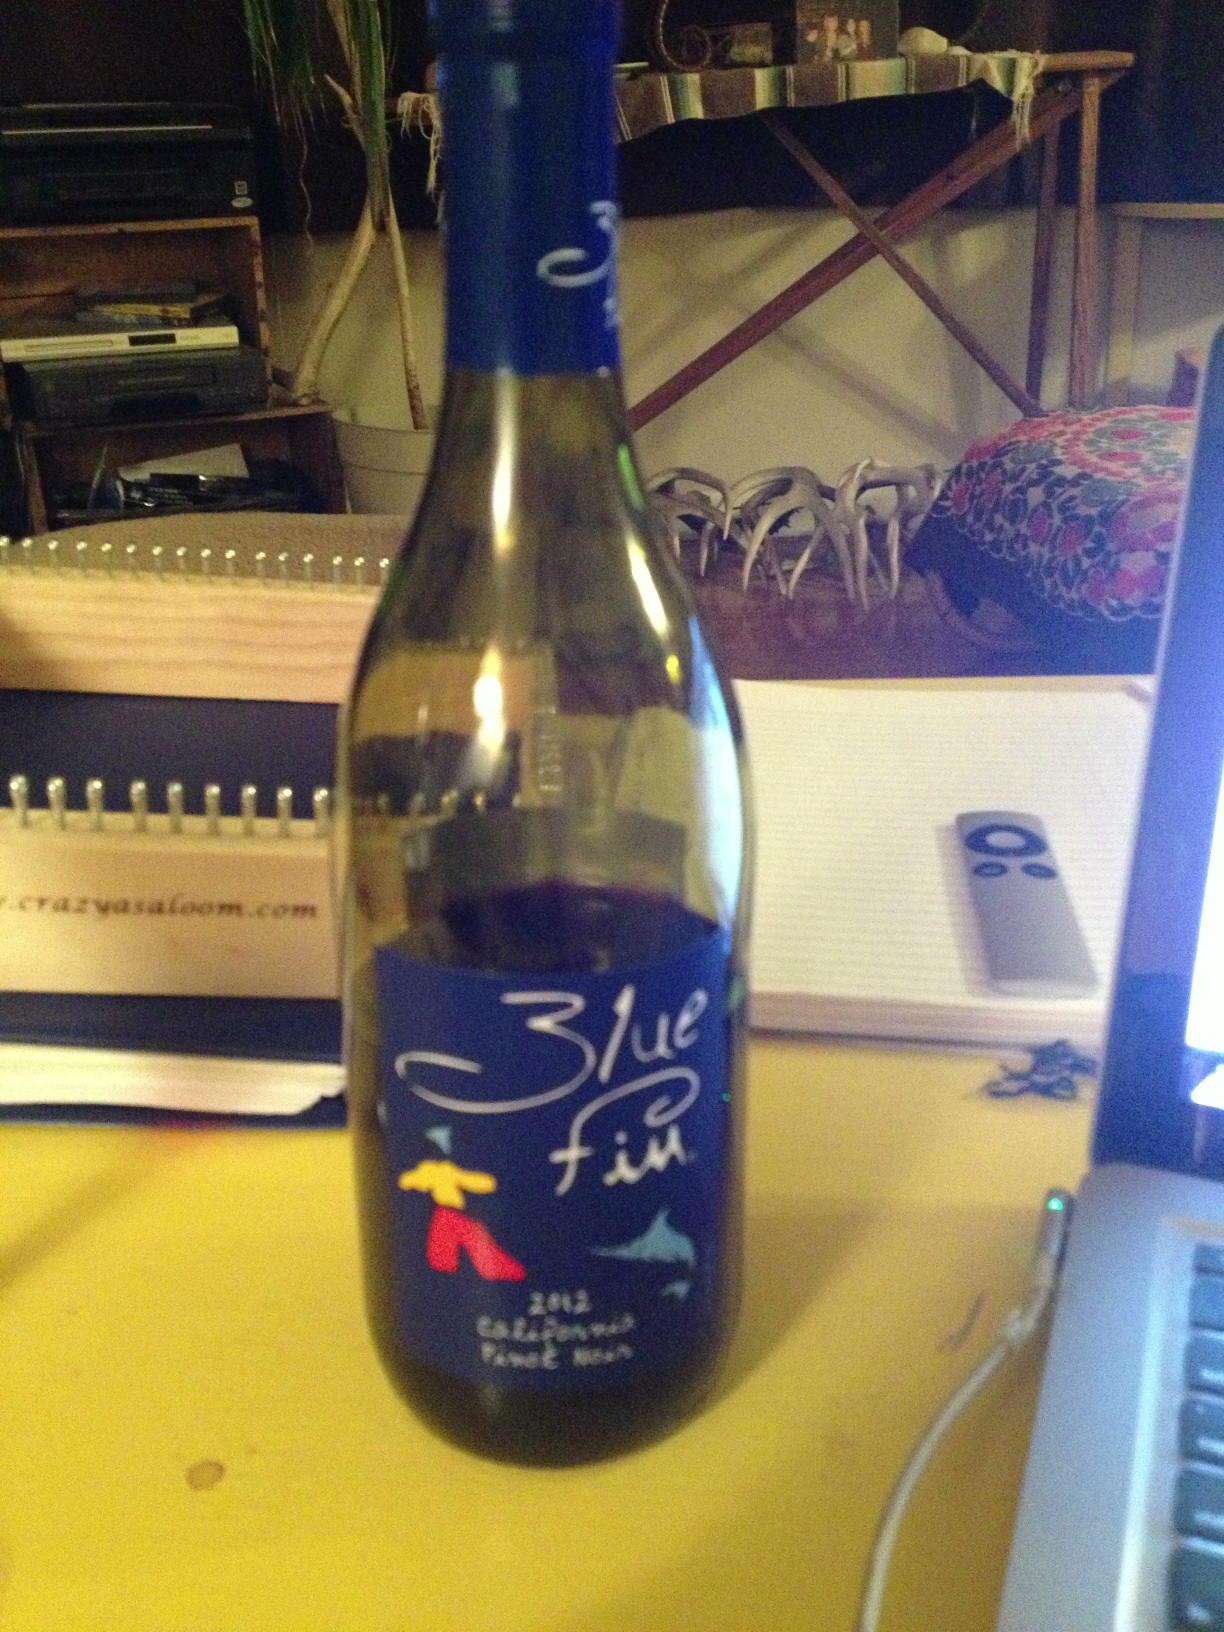What does this say? from Vizwiz blue fin 